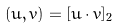<formula> <loc_0><loc_0><loc_500><loc_500>( u , v ) = [ u \cdot v ] _ { 2 }</formula> 